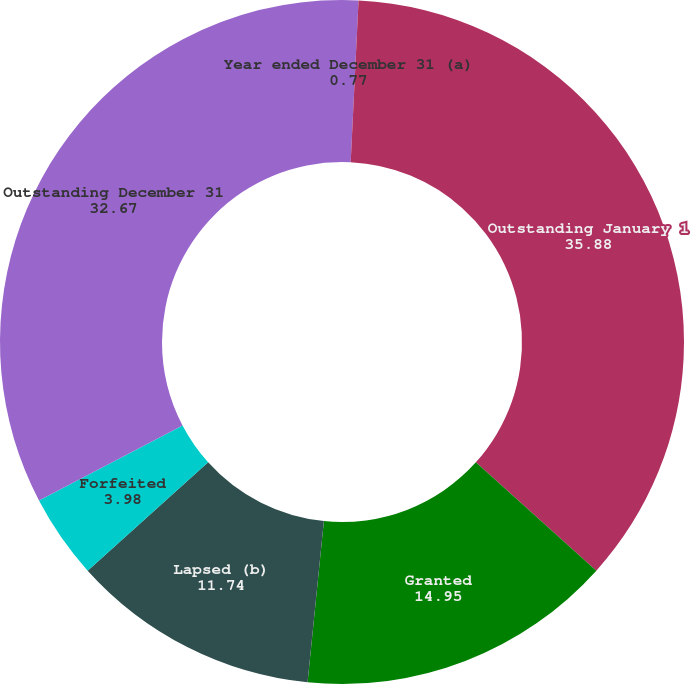<chart> <loc_0><loc_0><loc_500><loc_500><pie_chart><fcel>Year ended December 31 (a)<fcel>Outstanding January 1<fcel>Granted<fcel>Lapsed (b)<fcel>Forfeited<fcel>Outstanding December 31<nl><fcel>0.77%<fcel>35.88%<fcel>14.95%<fcel>11.74%<fcel>3.98%<fcel>32.67%<nl></chart> 